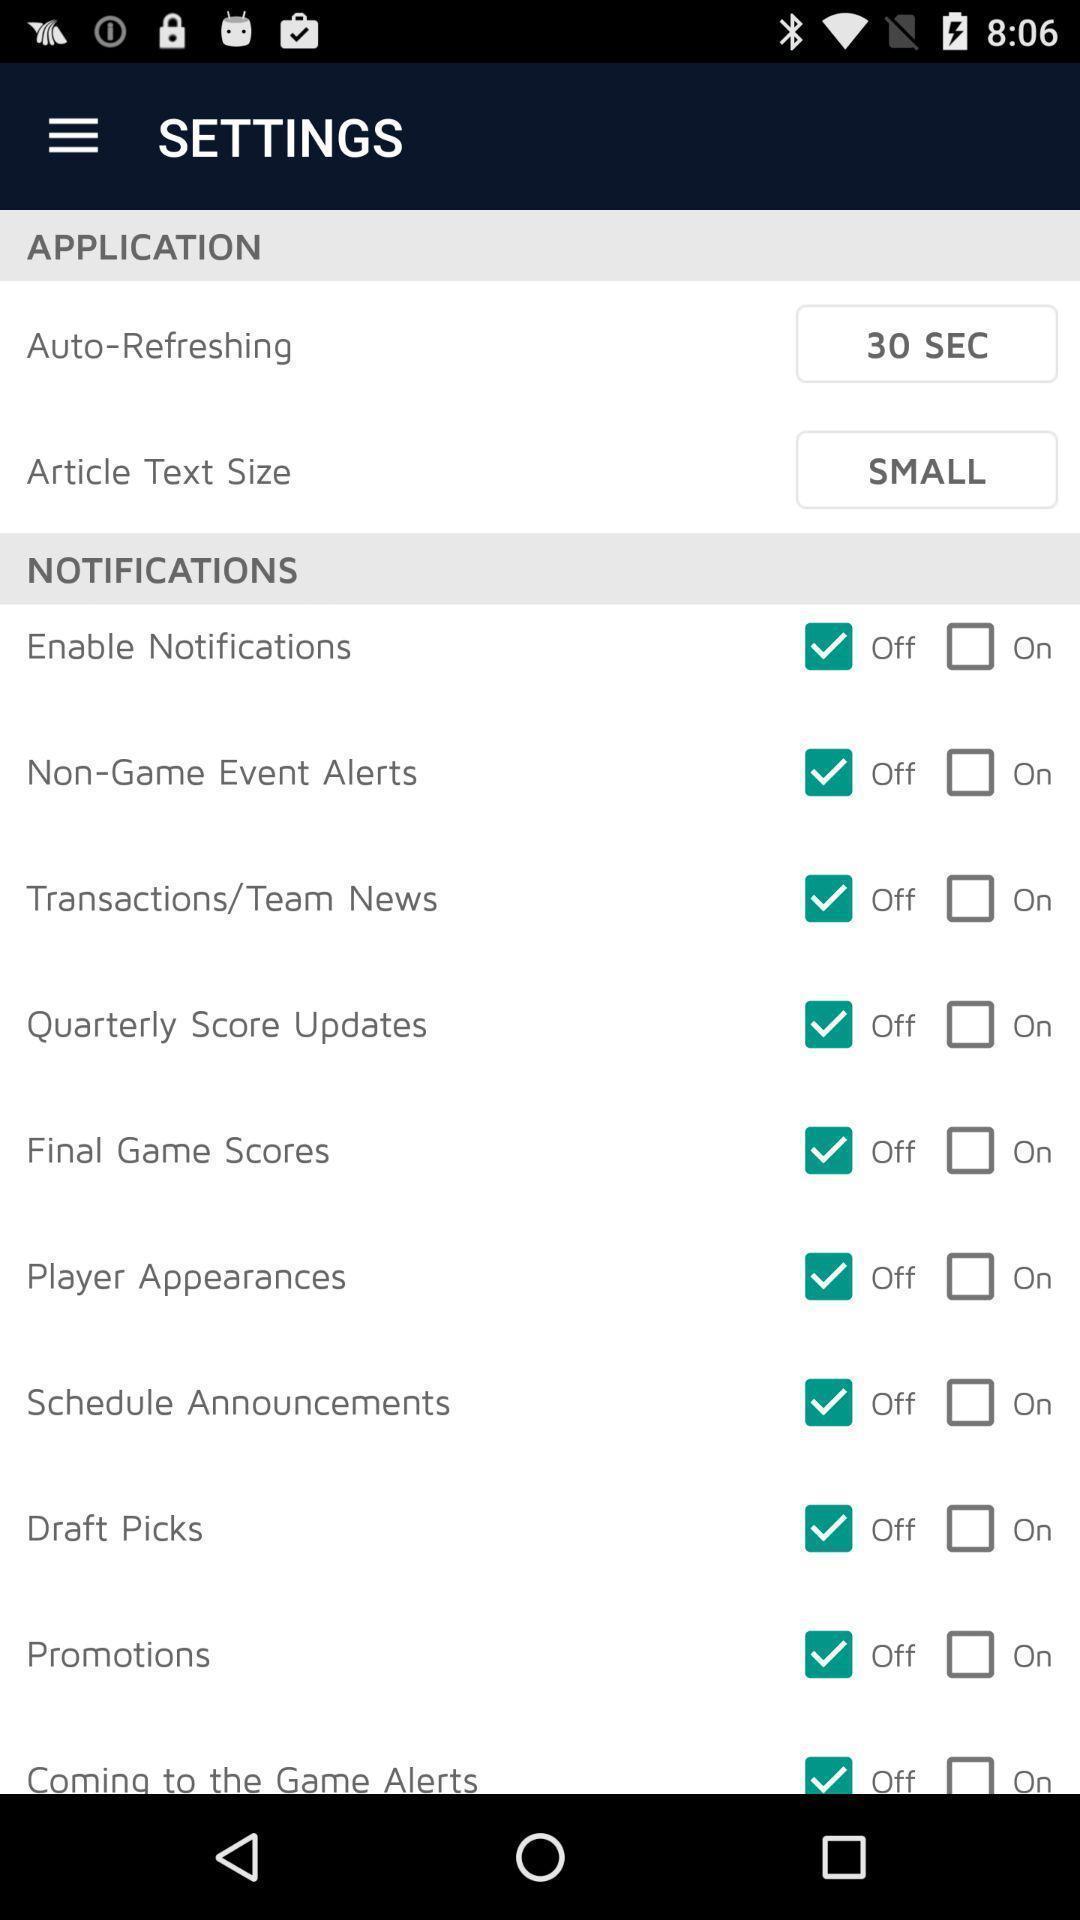Please provide a description for this image. Settings page in a mobile app. 